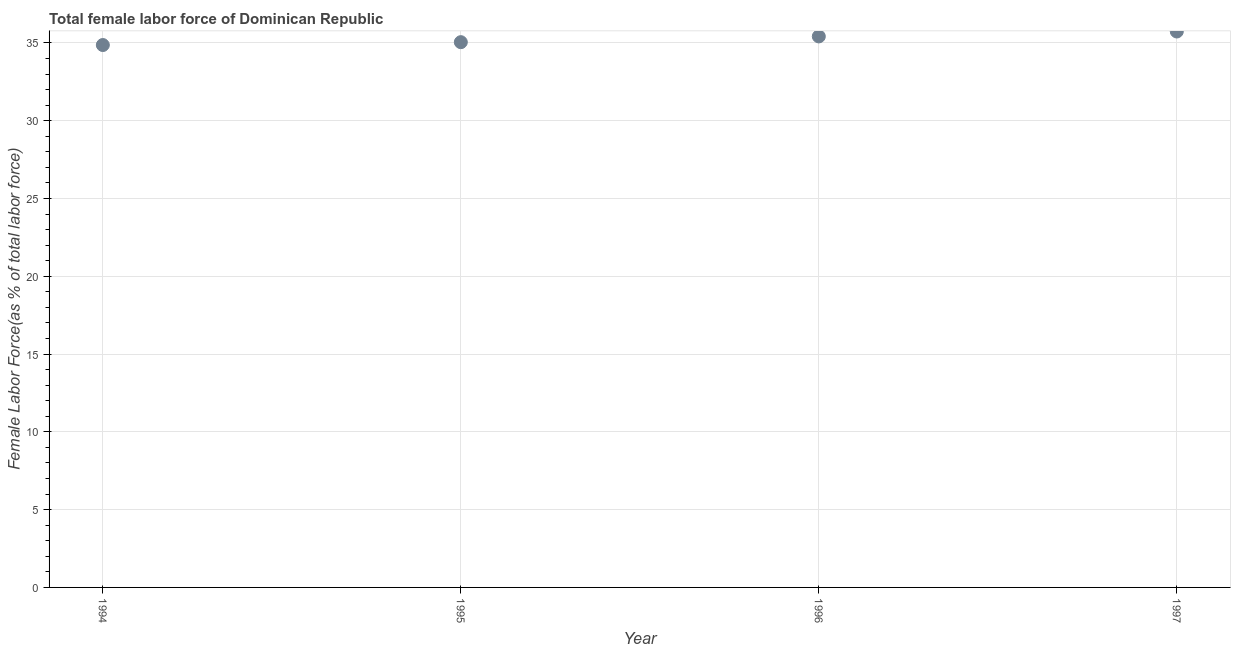What is the total female labor force in 1997?
Your answer should be compact. 35.74. Across all years, what is the maximum total female labor force?
Make the answer very short. 35.74. Across all years, what is the minimum total female labor force?
Your answer should be compact. 34.87. In which year was the total female labor force maximum?
Provide a succinct answer. 1997. What is the sum of the total female labor force?
Offer a terse response. 141.08. What is the difference between the total female labor force in 1996 and 1997?
Provide a short and direct response. -0.32. What is the average total female labor force per year?
Your answer should be very brief. 35.27. What is the median total female labor force?
Your response must be concise. 35.24. What is the ratio of the total female labor force in 1994 to that in 1995?
Your answer should be very brief. 0.99. Is the total female labor force in 1994 less than that in 1996?
Your response must be concise. Yes. Is the difference between the total female labor force in 1996 and 1997 greater than the difference between any two years?
Give a very brief answer. No. What is the difference between the highest and the second highest total female labor force?
Offer a very short reply. 0.32. Is the sum of the total female labor force in 1995 and 1996 greater than the maximum total female labor force across all years?
Give a very brief answer. Yes. What is the difference between the highest and the lowest total female labor force?
Offer a very short reply. 0.87. In how many years, is the total female labor force greater than the average total female labor force taken over all years?
Offer a very short reply. 2. How many dotlines are there?
Your answer should be very brief. 1. What is the difference between two consecutive major ticks on the Y-axis?
Offer a very short reply. 5. Are the values on the major ticks of Y-axis written in scientific E-notation?
Your answer should be very brief. No. Does the graph contain grids?
Make the answer very short. Yes. What is the title of the graph?
Provide a succinct answer. Total female labor force of Dominican Republic. What is the label or title of the Y-axis?
Offer a terse response. Female Labor Force(as % of total labor force). What is the Female Labor Force(as % of total labor force) in 1994?
Provide a short and direct response. 34.87. What is the Female Labor Force(as % of total labor force) in 1995?
Your answer should be very brief. 35.05. What is the Female Labor Force(as % of total labor force) in 1996?
Your answer should be compact. 35.42. What is the Female Labor Force(as % of total labor force) in 1997?
Provide a succinct answer. 35.74. What is the difference between the Female Labor Force(as % of total labor force) in 1994 and 1995?
Provide a short and direct response. -0.18. What is the difference between the Female Labor Force(as % of total labor force) in 1994 and 1996?
Provide a succinct answer. -0.55. What is the difference between the Female Labor Force(as % of total labor force) in 1994 and 1997?
Offer a very short reply. -0.87. What is the difference between the Female Labor Force(as % of total labor force) in 1995 and 1996?
Keep it short and to the point. -0.37. What is the difference between the Female Labor Force(as % of total labor force) in 1995 and 1997?
Offer a very short reply. -0.69. What is the difference between the Female Labor Force(as % of total labor force) in 1996 and 1997?
Provide a short and direct response. -0.32. What is the ratio of the Female Labor Force(as % of total labor force) in 1994 to that in 1997?
Your response must be concise. 0.98. What is the ratio of the Female Labor Force(as % of total labor force) in 1995 to that in 1996?
Make the answer very short. 0.99. What is the ratio of the Female Labor Force(as % of total labor force) in 1995 to that in 1997?
Provide a short and direct response. 0.98. 